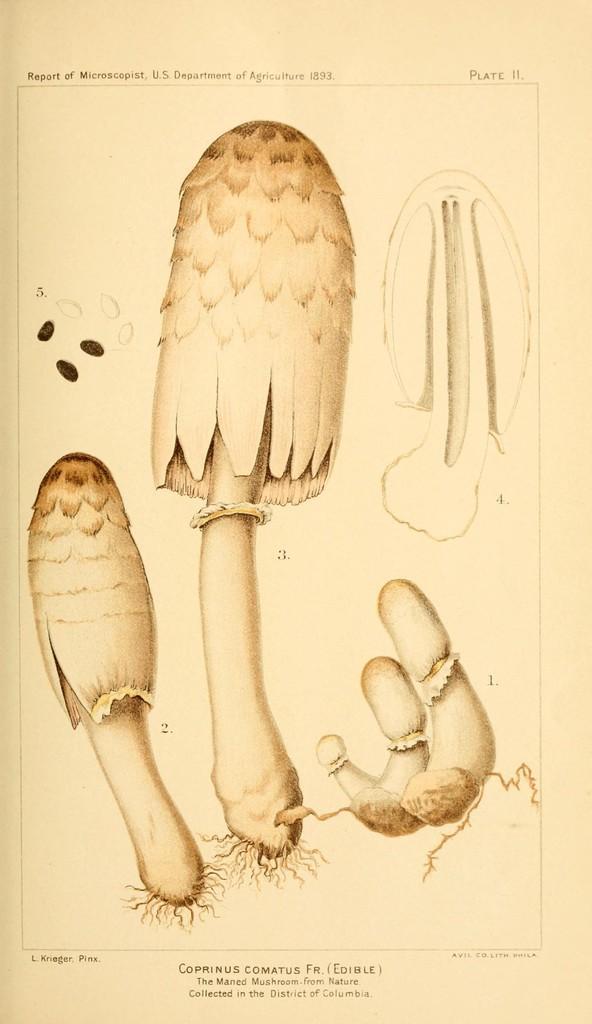Could you give a brief overview of what you see in this image? This is a paper. In the center of the image we can see mushrooms. At top and bottom of the image we can see some text. 